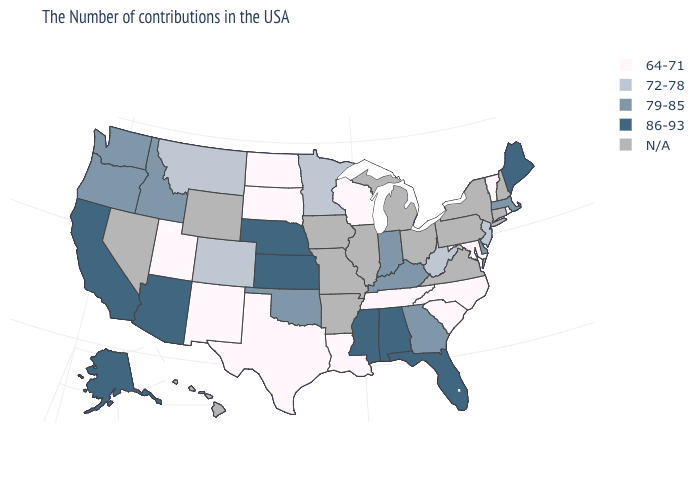Name the states that have a value in the range 72-78?
Concise answer only. New Jersey, West Virginia, Minnesota, Colorado, Montana. What is the value of Colorado?
Give a very brief answer. 72-78. Name the states that have a value in the range N/A?
Concise answer only. New Hampshire, Connecticut, New York, Pennsylvania, Virginia, Ohio, Michigan, Illinois, Missouri, Arkansas, Iowa, Wyoming, Nevada, Hawaii. Name the states that have a value in the range 72-78?
Write a very short answer. New Jersey, West Virginia, Minnesota, Colorado, Montana. Which states hav the highest value in the MidWest?
Concise answer only. Kansas, Nebraska. Which states have the lowest value in the South?
Write a very short answer. Maryland, North Carolina, South Carolina, Tennessee, Louisiana, Texas. Which states have the highest value in the USA?
Answer briefly. Maine, Florida, Alabama, Mississippi, Kansas, Nebraska, Arizona, California, Alaska. How many symbols are there in the legend?
Concise answer only. 5. What is the value of Missouri?
Short answer required. N/A. Among the states that border Idaho , which have the lowest value?
Write a very short answer. Utah. What is the value of Idaho?
Be succinct. 79-85. What is the value of Pennsylvania?
Short answer required. N/A. Does Maine have the lowest value in the Northeast?
Write a very short answer. No. Among the states that border Maryland , which have the highest value?
Write a very short answer. Delaware. 